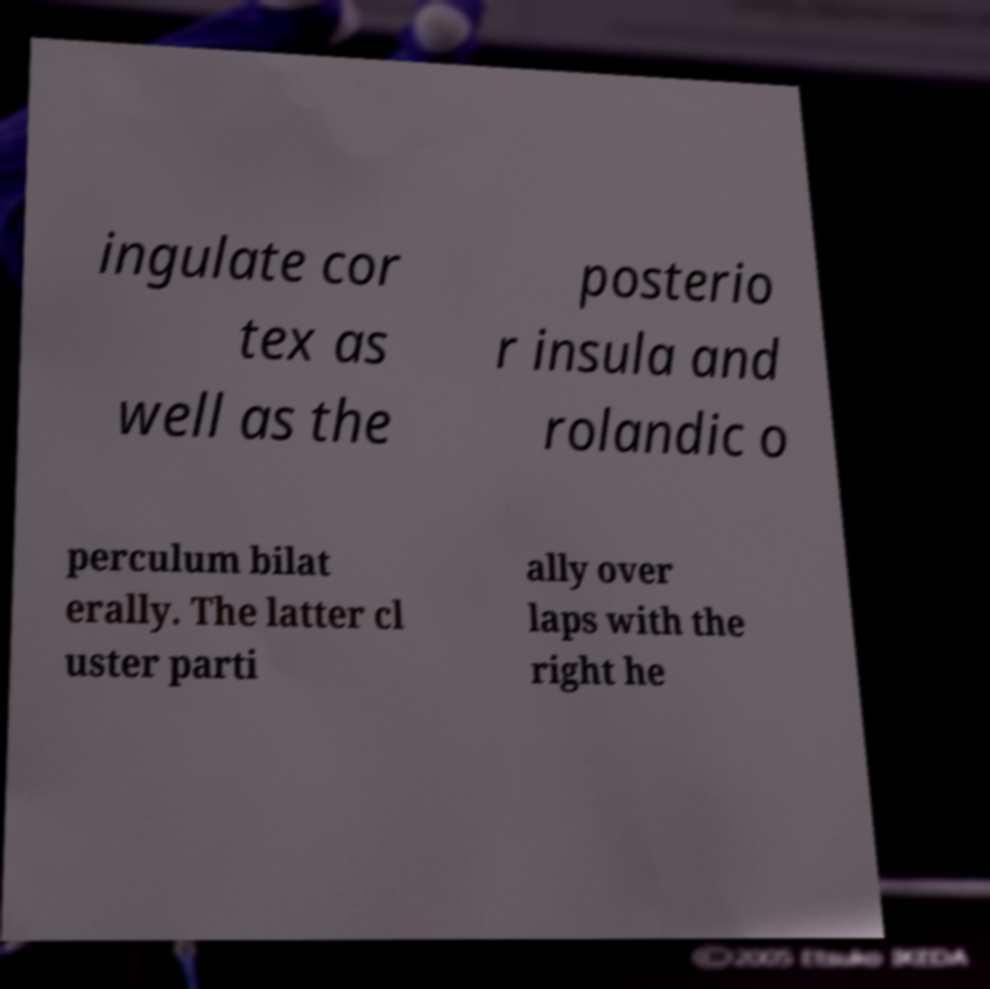Could you assist in decoding the text presented in this image and type it out clearly? ingulate cor tex as well as the posterio r insula and rolandic o perculum bilat erally. The latter cl uster parti ally over laps with the right he 